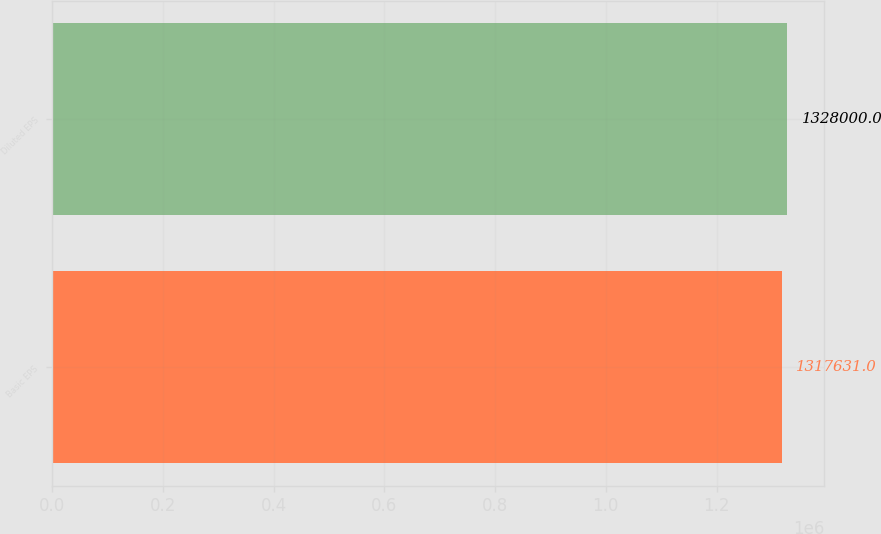Convert chart to OTSL. <chart><loc_0><loc_0><loc_500><loc_500><bar_chart><fcel>Basic EPS<fcel>Diluted EPS<nl><fcel>1.31763e+06<fcel>1.328e+06<nl></chart> 